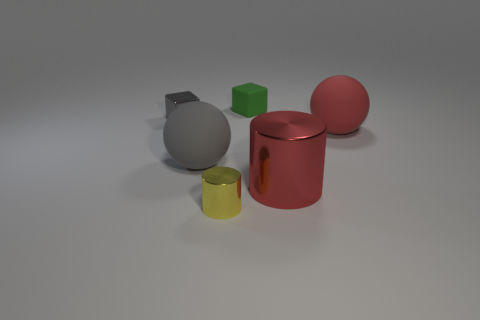What color is the metal block?
Give a very brief answer. Gray. There is a sphere that is the same color as the big metal cylinder; what is it made of?
Your answer should be compact. Rubber. Is there a small yellow metallic thing that has the same shape as the large gray rubber thing?
Provide a short and direct response. No. There is a thing that is behind the gray metallic block; what size is it?
Provide a succinct answer. Small. What material is the green thing that is the same size as the gray metal thing?
Your response must be concise. Rubber. Is the number of tiny cylinders greater than the number of big blue cylinders?
Your answer should be very brief. Yes. How big is the gray thing to the left of the large rubber object that is to the left of the small yellow thing?
Ensure brevity in your answer.  Small. What is the shape of the rubber thing that is the same size as the gray rubber sphere?
Keep it short and to the point. Sphere. The tiny thing to the right of the shiny cylinder left of the metallic cylinder to the right of the green matte thing is what shape?
Offer a very short reply. Cube. Is the color of the block on the right side of the metal block the same as the rubber object that is to the right of the small green matte cube?
Provide a short and direct response. No. 